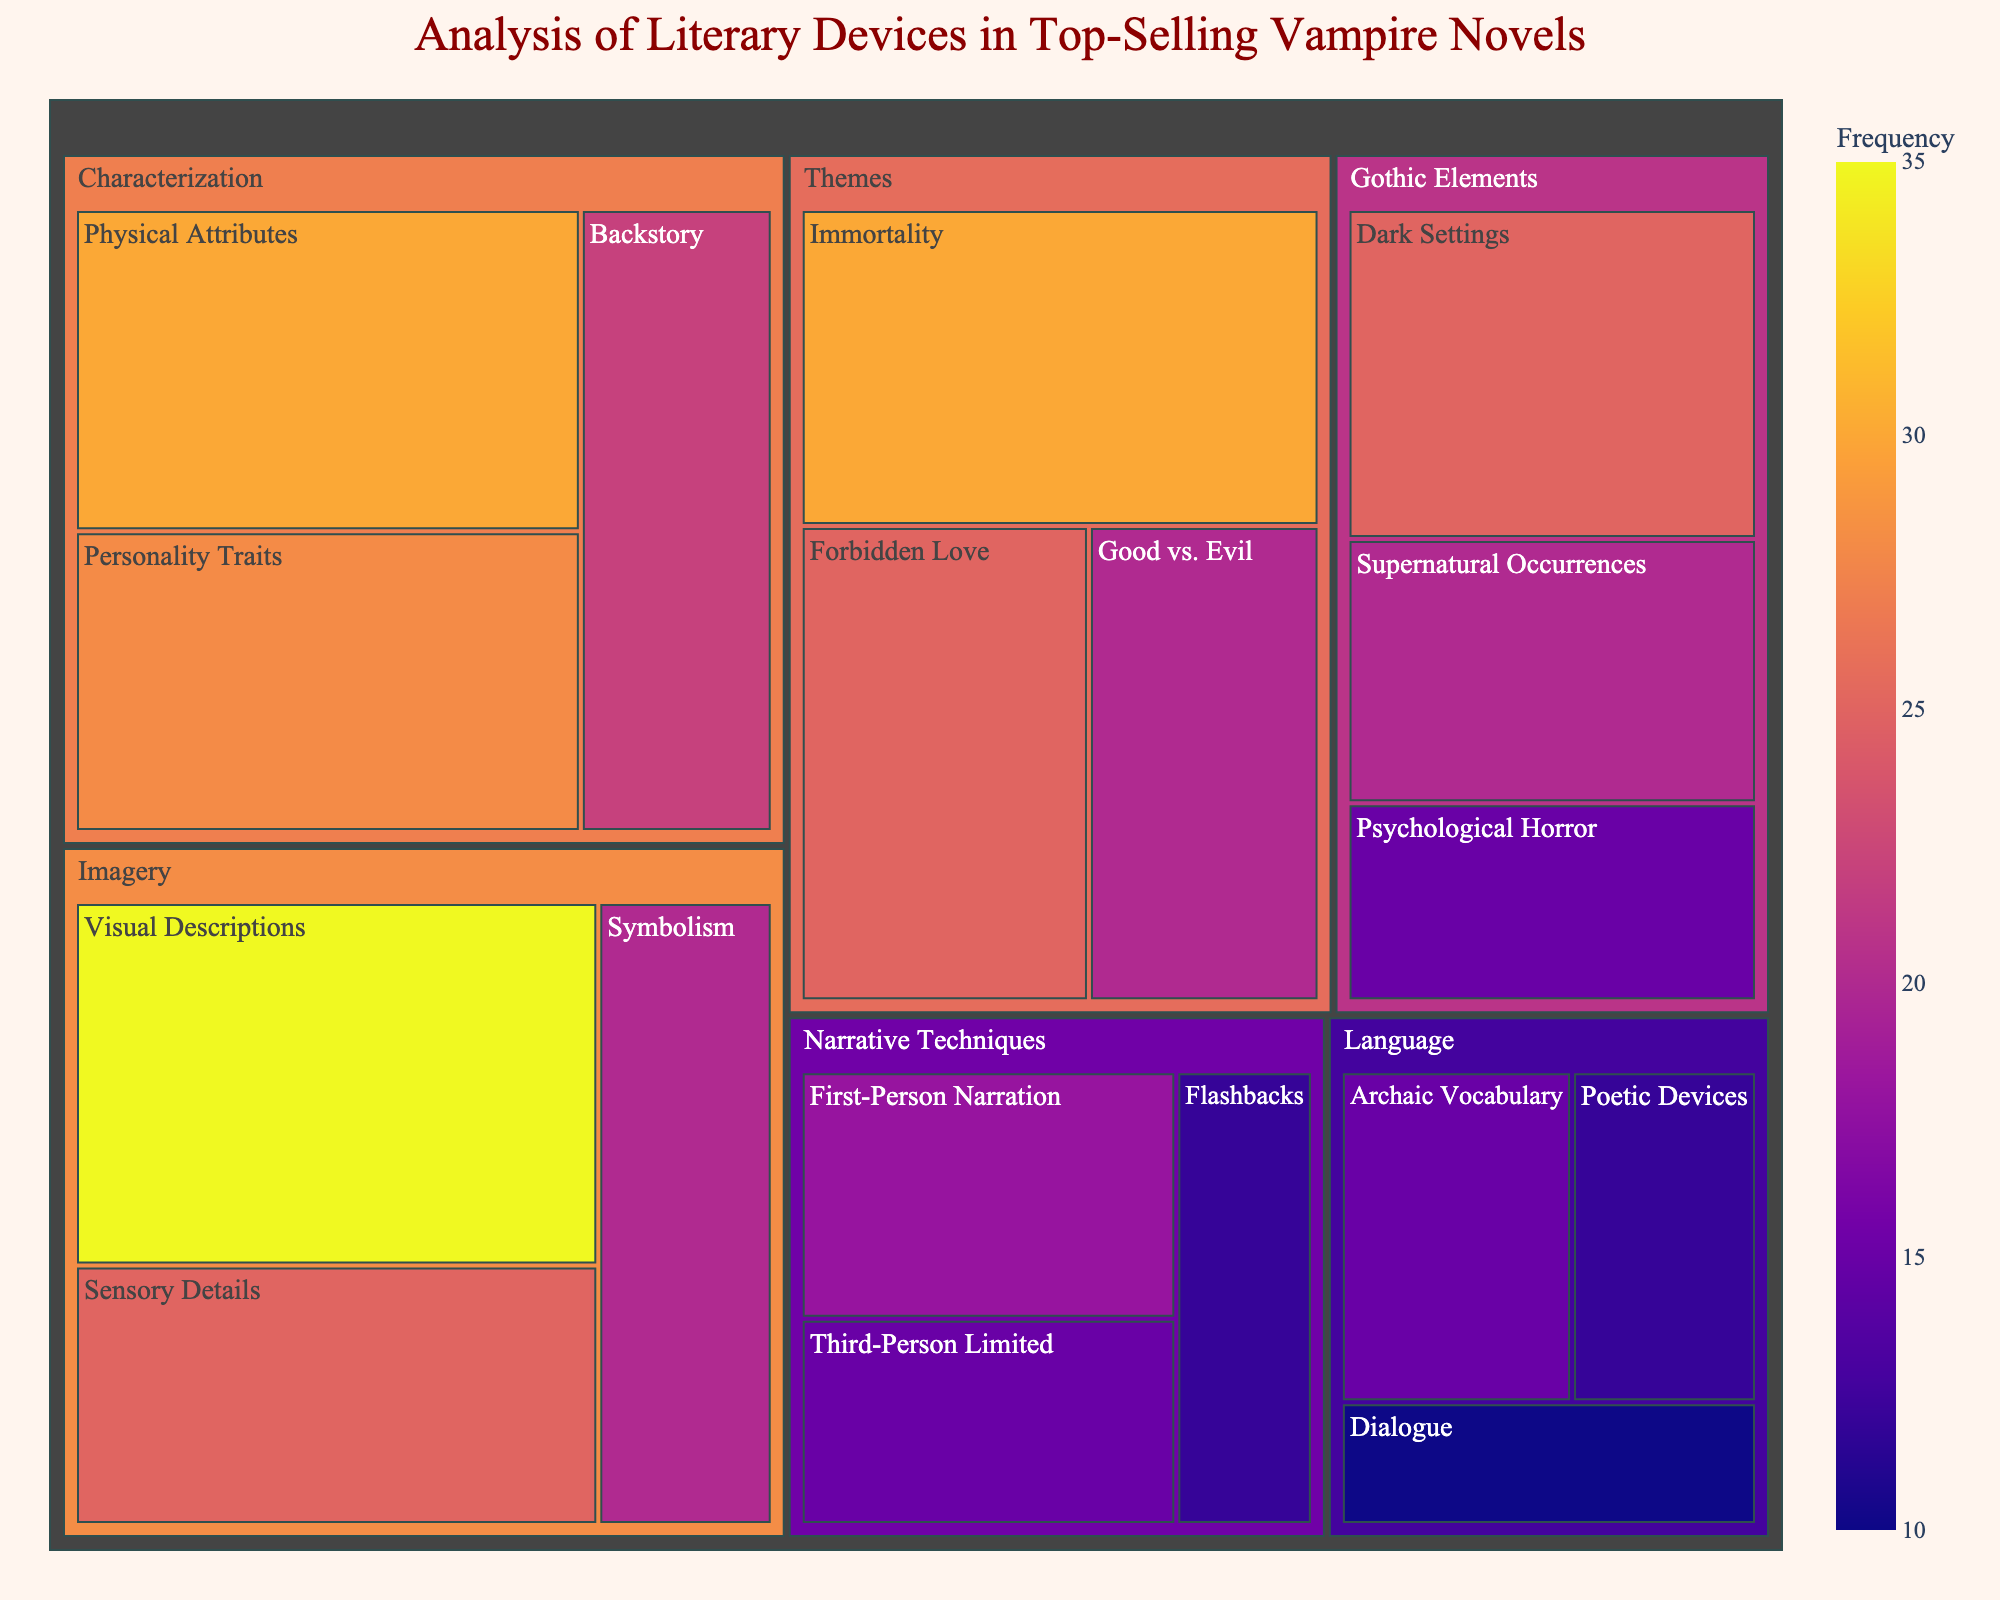What is the most frequently used subcategory in Imagery? The subcategory Visual Descriptions has the highest value within the Imagery category, with a frequency of 35.
Answer: Visual Descriptions Which category has the highest total frequency? By summing the values of all subcategories within each category, Characterization has the highest total frequency (30 + 28 + 22 = 80).
Answer: Characterization How does the frequency of Gothic Elements' Dark Settings compare to that of Themes' Immortality? Dark Settings and Immortality both have a frequency of 25 and 30, respectively. Immortality has a higher frequency by 5.
Answer: Immortality is higher by 5 What is the combined frequency of Narrative Techniques' First-Person Narration and Third-Person Limited? Summing the values of First-Person Narration (18) and Third-Person Limited (15) gives 18 + 15 = 33.
Answer: 33 Which subcategory has the lowest frequency within the Language category? Dialogue has the lowest frequency among the subcategories in Language with a value of 10.
Answer: Dialogue What is the average frequency of the subcategories within Themes? The average frequency is found by summing the values (30 + 25 + 20 = 75) and dividing by the number of subcategories (3). The average is 75 / 3 = 25.
Answer: 25 Compare the frequency of imagery and narrative techniques. Summing the values for Imagery (35 + 25 + 20 = 80) and Narrative Techniques (18 + 15 + 12 = 45), Imagery has a higher frequency by 80 - 45 = 35.
Answer: Imagery is higher by 35 Which subcategory of Characterization has a frequency closest to the highest subcategory of Gothic Elements? The highest value in Gothic Elements is Dark Settings (25), and in Characterization, Personality Traits is the closest with a frequency of 28.
Answer: Personality Traits How many subcategories are there in total in the figure? Summing the number of subcategories from each category: 3 (Imagery) + 3 (Characterization) + 3 (Narrative Techniques) + 3 (Gothic Elements) + 3 (Themes) + 3 (Language) totals 18.
Answer: 18 